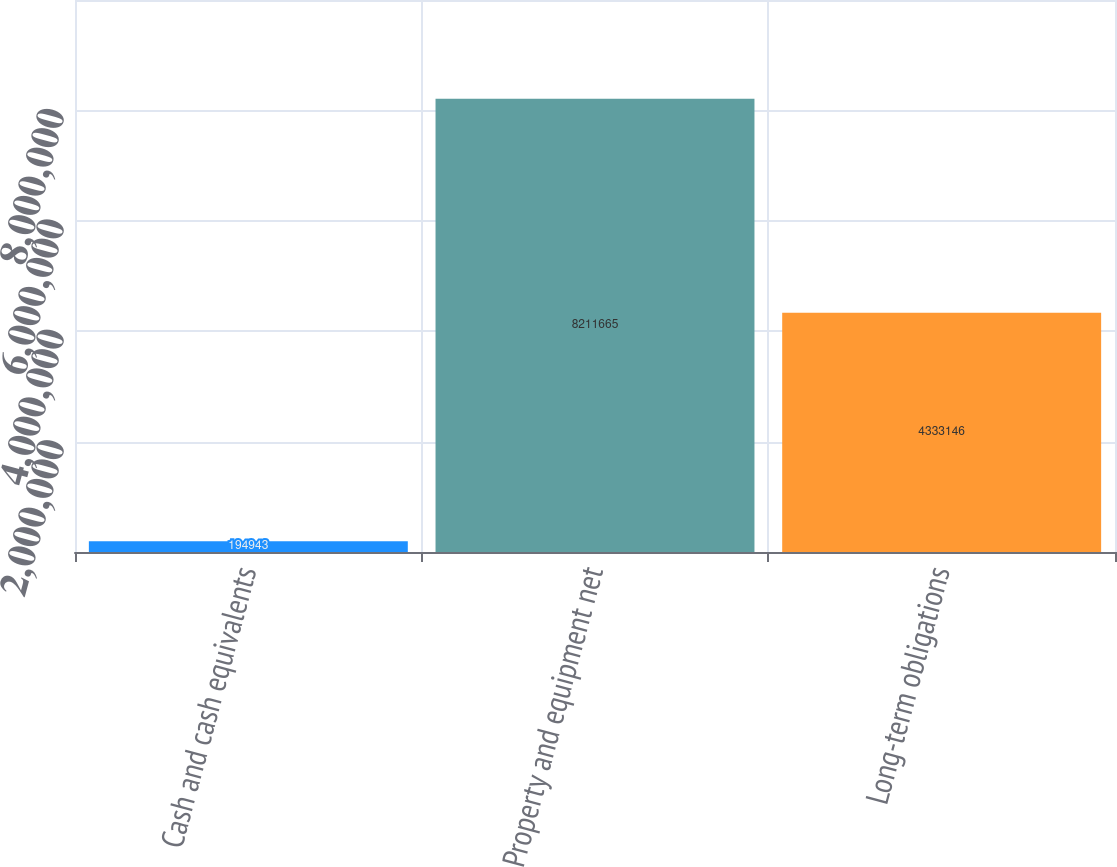Convert chart. <chart><loc_0><loc_0><loc_500><loc_500><bar_chart><fcel>Cash and cash equivalents<fcel>Property and equipment net<fcel>Long-term obligations<nl><fcel>194943<fcel>8.21166e+06<fcel>4.33315e+06<nl></chart> 